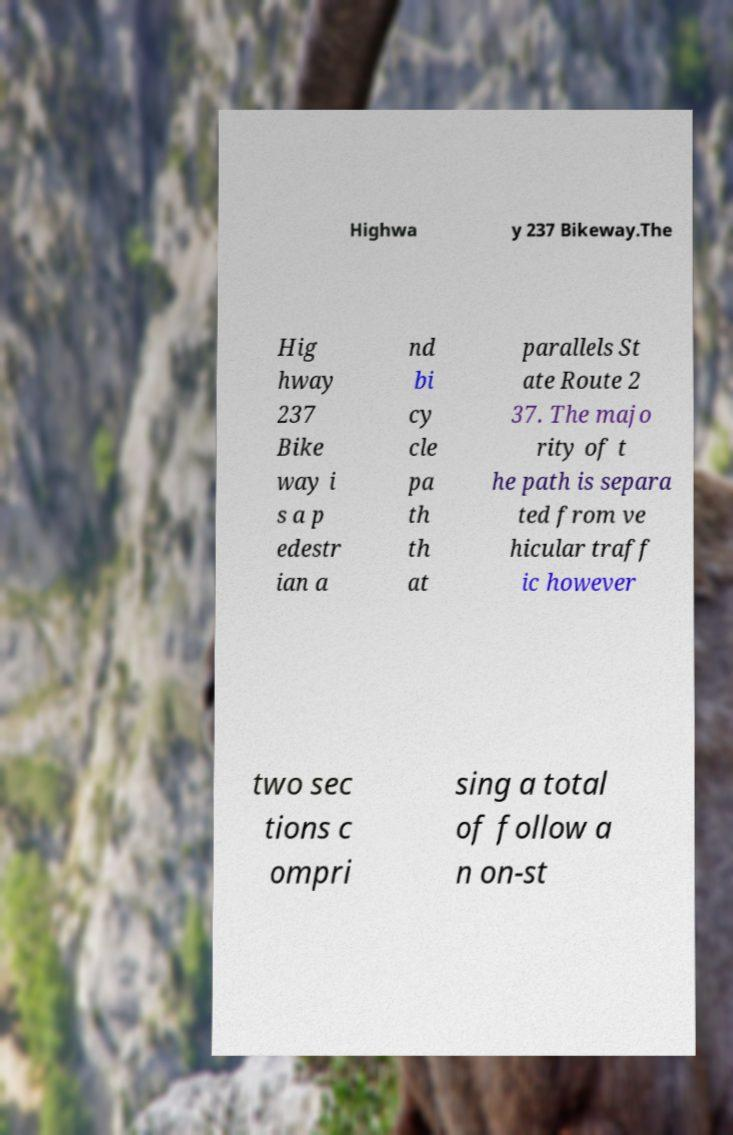Please identify and transcribe the text found in this image. Highwa y 237 Bikeway.The Hig hway 237 Bike way i s a p edestr ian a nd bi cy cle pa th th at parallels St ate Route 2 37. The majo rity of t he path is separa ted from ve hicular traff ic however two sec tions c ompri sing a total of follow a n on-st 